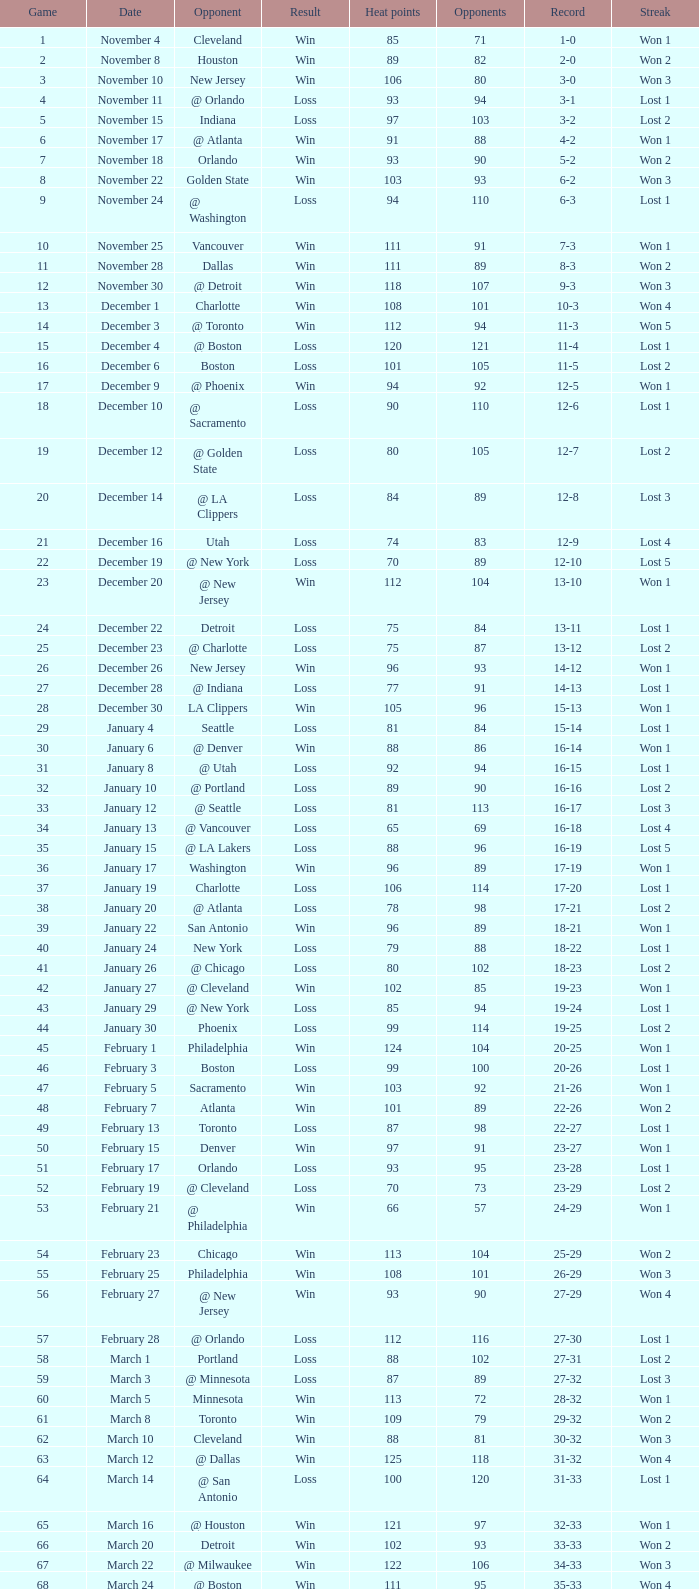What is Streak, when Heat Points is "101", and when Game is "16"? Lost 2. 